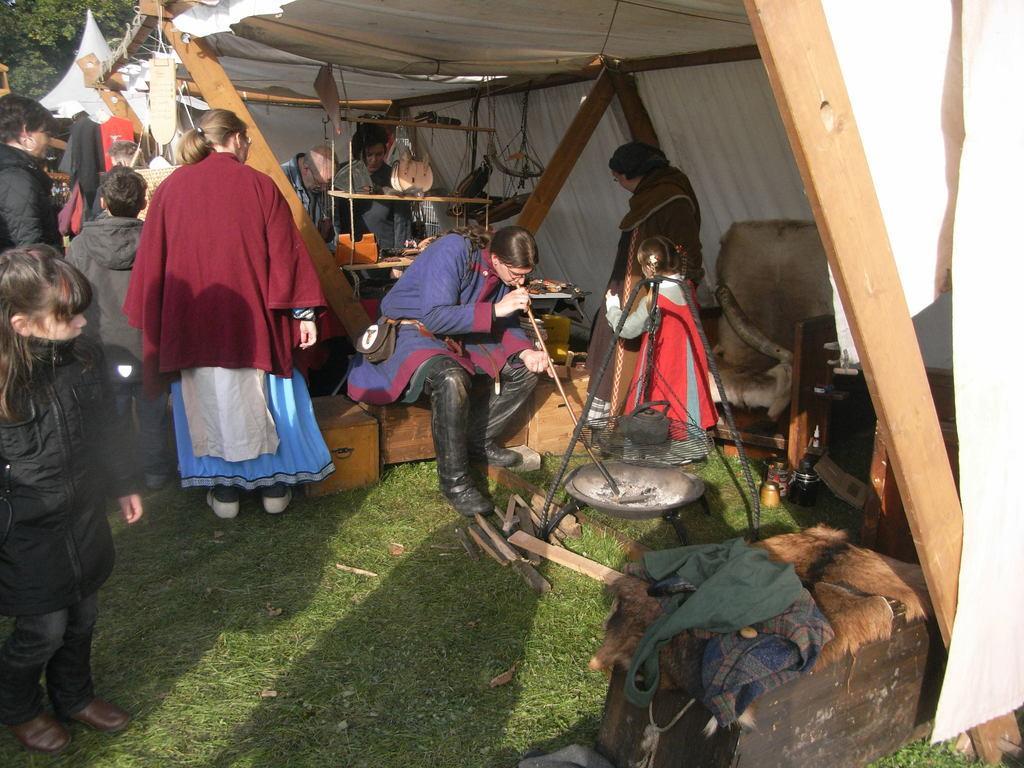Can you describe this image briefly? In this image I can see group of people, some are standing and some are sitting. In front the person is wearing maroon, white and blue color dress and I can few objects. In the background the tent is in white color, few trees in green color. 